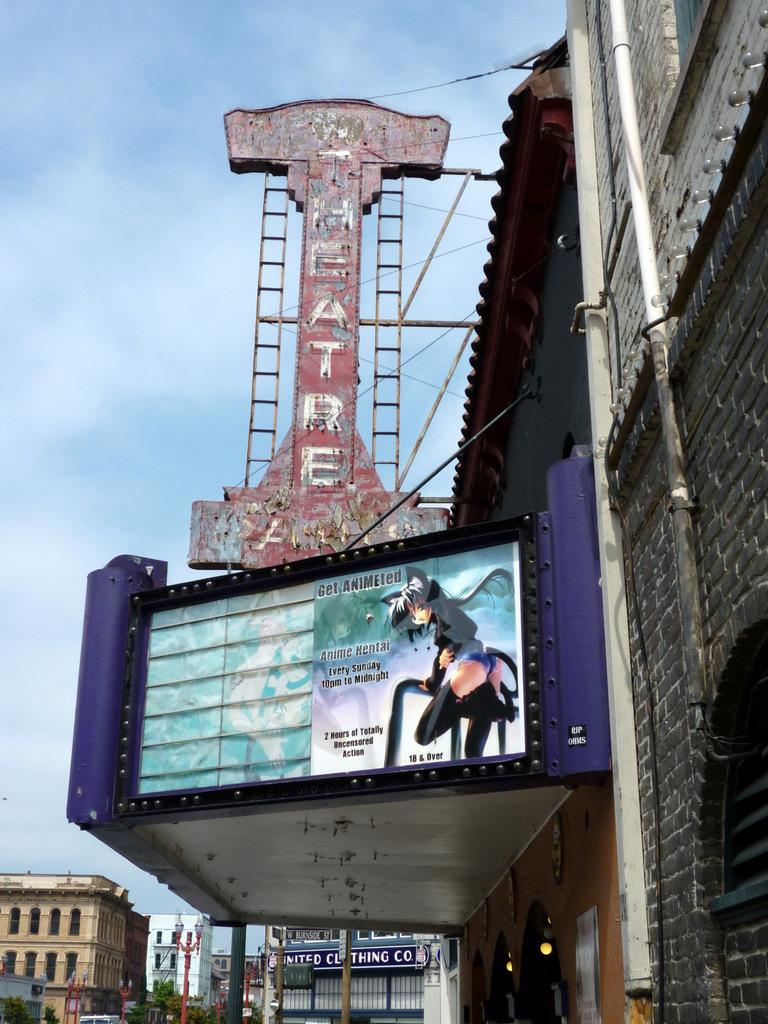<image>
Relay a brief, clear account of the picture shown. The marquis for an old theater has a sign advertising Anime Hentai, Every Sunday 10 pm to midnight. 